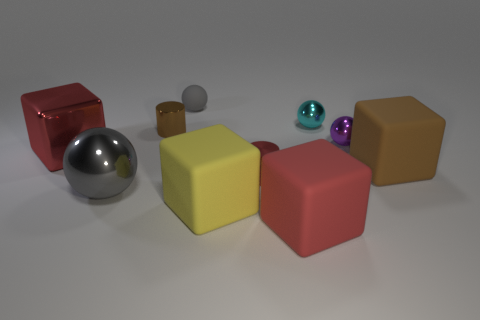Is the number of small purple shiny balls less than the number of red things?
Offer a terse response. Yes. Is the material of the big red thing that is on the left side of the tiny gray rubber sphere the same as the small brown thing?
Offer a very short reply. Yes. Are there any small red metal things in front of the large metallic ball?
Your answer should be compact. No. What is the color of the cylinder that is behind the small shiny cylinder that is in front of the large rubber block that is behind the yellow rubber thing?
Your response must be concise. Brown. There is a brown object that is the same size as the rubber ball; what shape is it?
Provide a short and direct response. Cylinder. Is the number of purple spheres greater than the number of tiny purple rubber blocks?
Provide a short and direct response. Yes. Are there any gray objects to the right of the gray object that is in front of the tiny purple ball?
Make the answer very short. Yes. There is another tiny rubber object that is the same shape as the purple object; what color is it?
Keep it short and to the point. Gray. What color is the tiny ball that is the same material as the small purple object?
Make the answer very short. Cyan. Is there a big metallic thing that is to the left of the big gray metal ball that is in front of the large cube that is on the left side of the small brown metallic thing?
Ensure brevity in your answer.  Yes. 